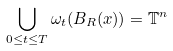<formula> <loc_0><loc_0><loc_500><loc_500>\bigcup _ { 0 \leq t \leq T } \omega _ { t } ( B _ { R } ( x ) ) = \mathbb { T } ^ { n }</formula> 